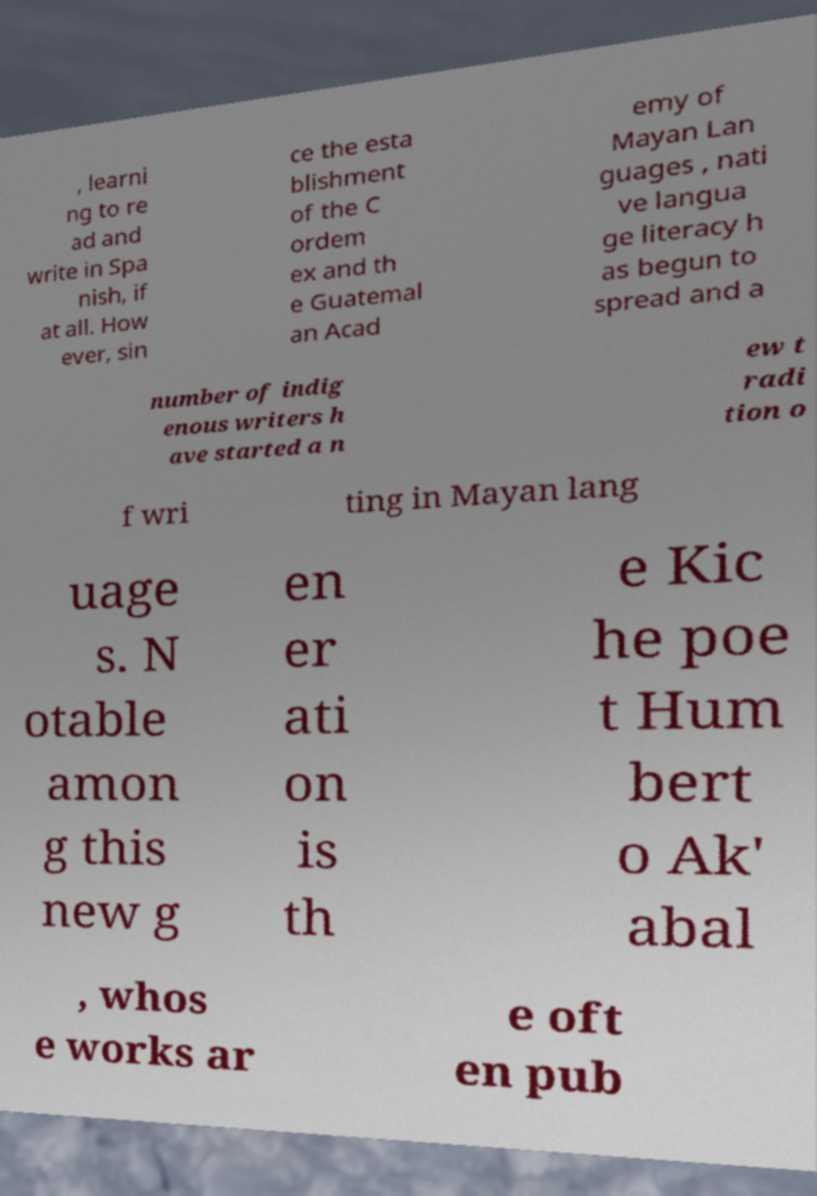Please identify and transcribe the text found in this image. , learni ng to re ad and write in Spa nish, if at all. How ever, sin ce the esta blishment of the C ordem ex and th e Guatemal an Acad emy of Mayan Lan guages , nati ve langua ge literacy h as begun to spread and a number of indig enous writers h ave started a n ew t radi tion o f wri ting in Mayan lang uage s. N otable amon g this new g en er ati on is th e Kic he poe t Hum bert o Ak' abal , whos e works ar e oft en pub 